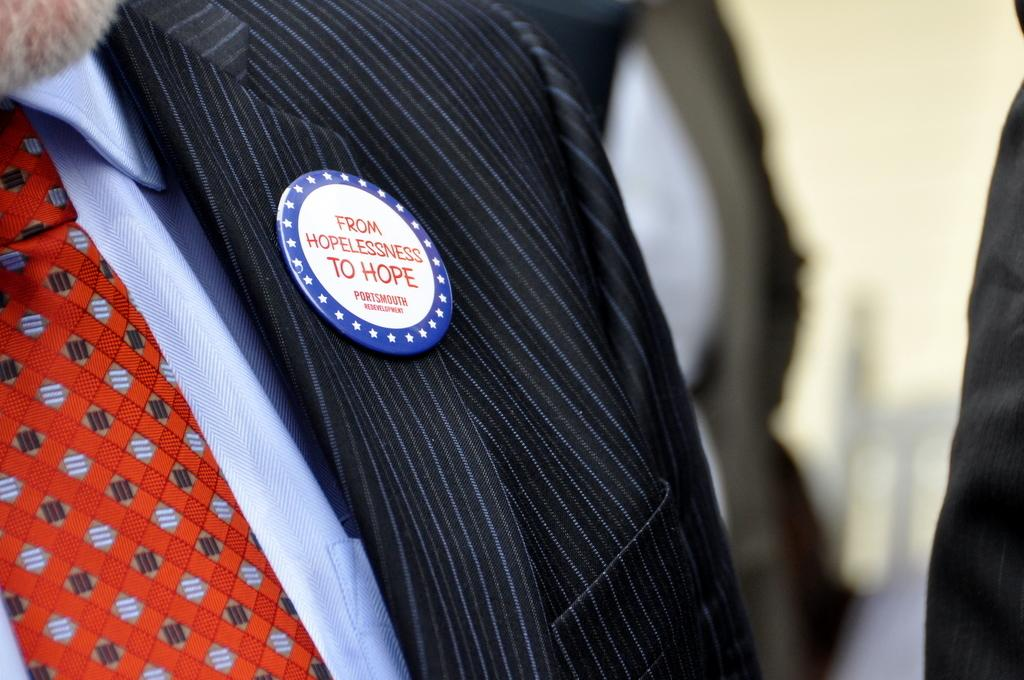What is on the suit that the person is wearing? There is a badge on a suit that the person is wearing. Can you describe the person wearing the badge? The person wearing the badge is not described in the provided facts. What can be observed about the background of the image? The background of the image is blurred. What type of waste is visible in the image? There is no waste present in the image. Who is the representative of the organization in the image? The provided facts do not mention any organization or representative. What is sparking in the image? There is no spark present in the image. 